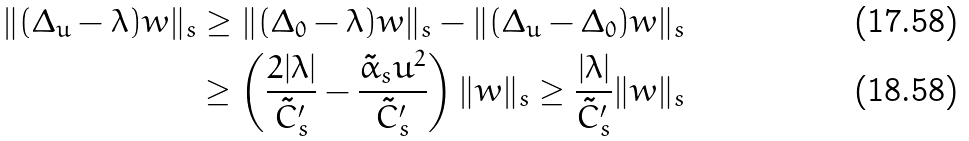<formula> <loc_0><loc_0><loc_500><loc_500>\| ( \Delta _ { u } - \lambda ) w \| _ { s } \geq \| ( \Delta _ { 0 } - \lambda ) w \| _ { s } - \| ( \Delta _ { u } - \Delta _ { 0 } ) w \| _ { s } \\ \geq \left ( \frac { 2 | \lambda | } { \tilde { C } _ { s } ^ { \prime } } - \frac { \tilde { \alpha } _ { s } u ^ { 2 } } { \tilde { C } _ { s } ^ { \prime } } \right ) \| w \| _ { s } \geq \frac { | \lambda | } { \tilde { C } _ { s } ^ { \prime } } \| w \| _ { s }</formula> 